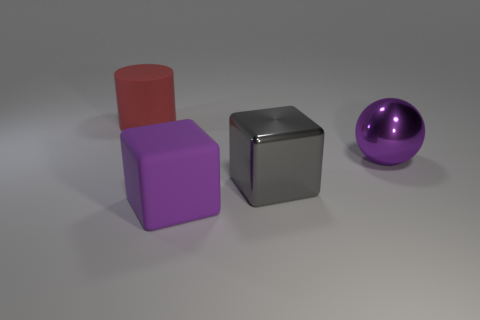What shape is the big purple matte thing?
Your answer should be compact. Cube. What is the material of the large cylinder left of the purple rubber object?
Provide a succinct answer. Rubber. There is a big rubber thing that is behind the large block that is behind the big rubber object that is in front of the gray object; what color is it?
Keep it short and to the point. Red. What is the color of the cylinder that is the same size as the gray cube?
Make the answer very short. Red. What number of metal things are gray cubes or large red objects?
Your response must be concise. 1. There is a large thing that is made of the same material as the big gray cube; what is its color?
Provide a succinct answer. Purple. What material is the big red cylinder that is behind the big purple object that is behind the matte cube made of?
Your answer should be very brief. Rubber. What number of objects are either large matte cylinders behind the purple rubber block or large things on the right side of the red cylinder?
Provide a succinct answer. 4. There is a thing to the left of the large rubber thing right of the large red matte cylinder that is on the left side of the ball; what size is it?
Your answer should be compact. Large. Is the number of shiny things that are in front of the purple shiny sphere the same as the number of large shiny objects?
Make the answer very short. No. 